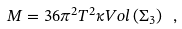Convert formula to latex. <formula><loc_0><loc_0><loc_500><loc_500>M = 3 6 \pi ^ { 2 } T ^ { 2 } \kappa V o l \left ( \Sigma _ { 3 } \right ) \ ,</formula> 